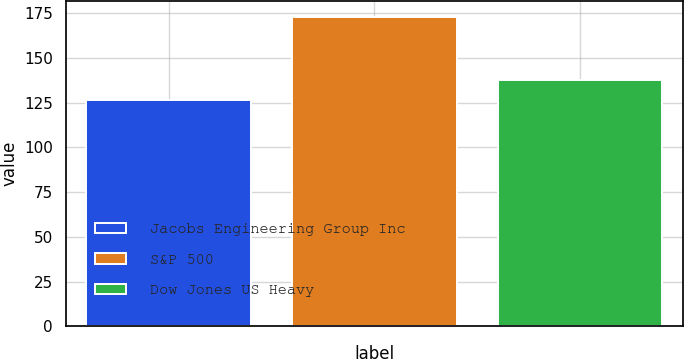Convert chart. <chart><loc_0><loc_0><loc_500><loc_500><bar_chart><fcel>Jacobs Engineering Group Inc<fcel>S&P 500<fcel>Dow Jones US Heavy<nl><fcel>126.62<fcel>173.13<fcel>137.4<nl></chart> 